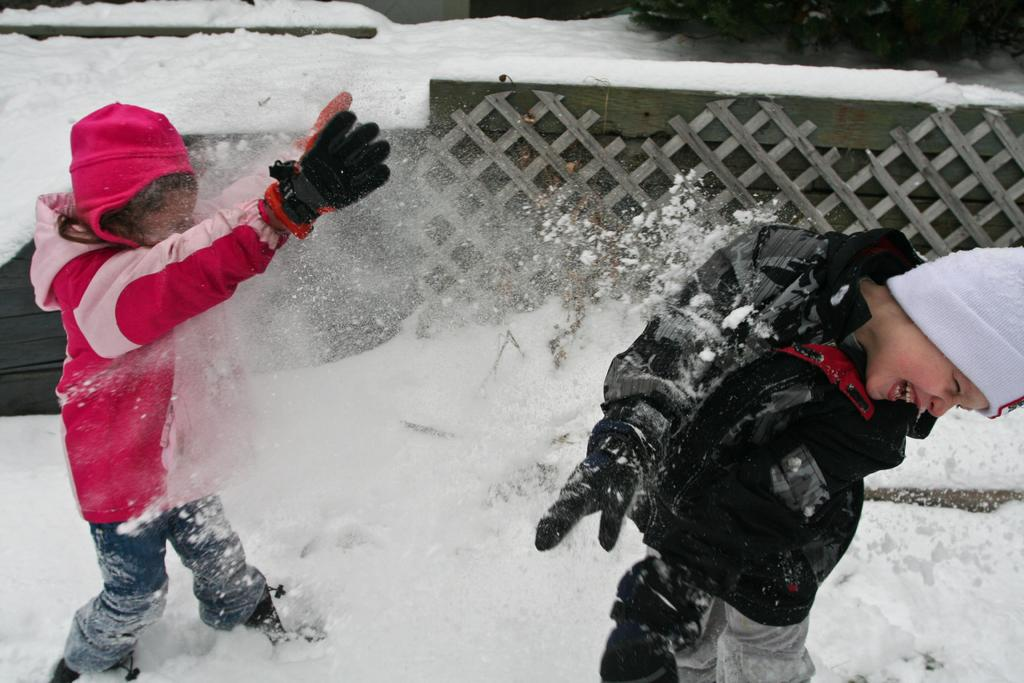How many kids are present in the image? There are two kids in the image. What are the kids doing in the image? The kids are playing in the snow. What type of barrier can be seen in the image? There is a wooden fence visible in the image. Where is the beggar standing in the image? There is no beggar present in the image. How many chickens can be seen in the image? There are no chickens present in the image. 